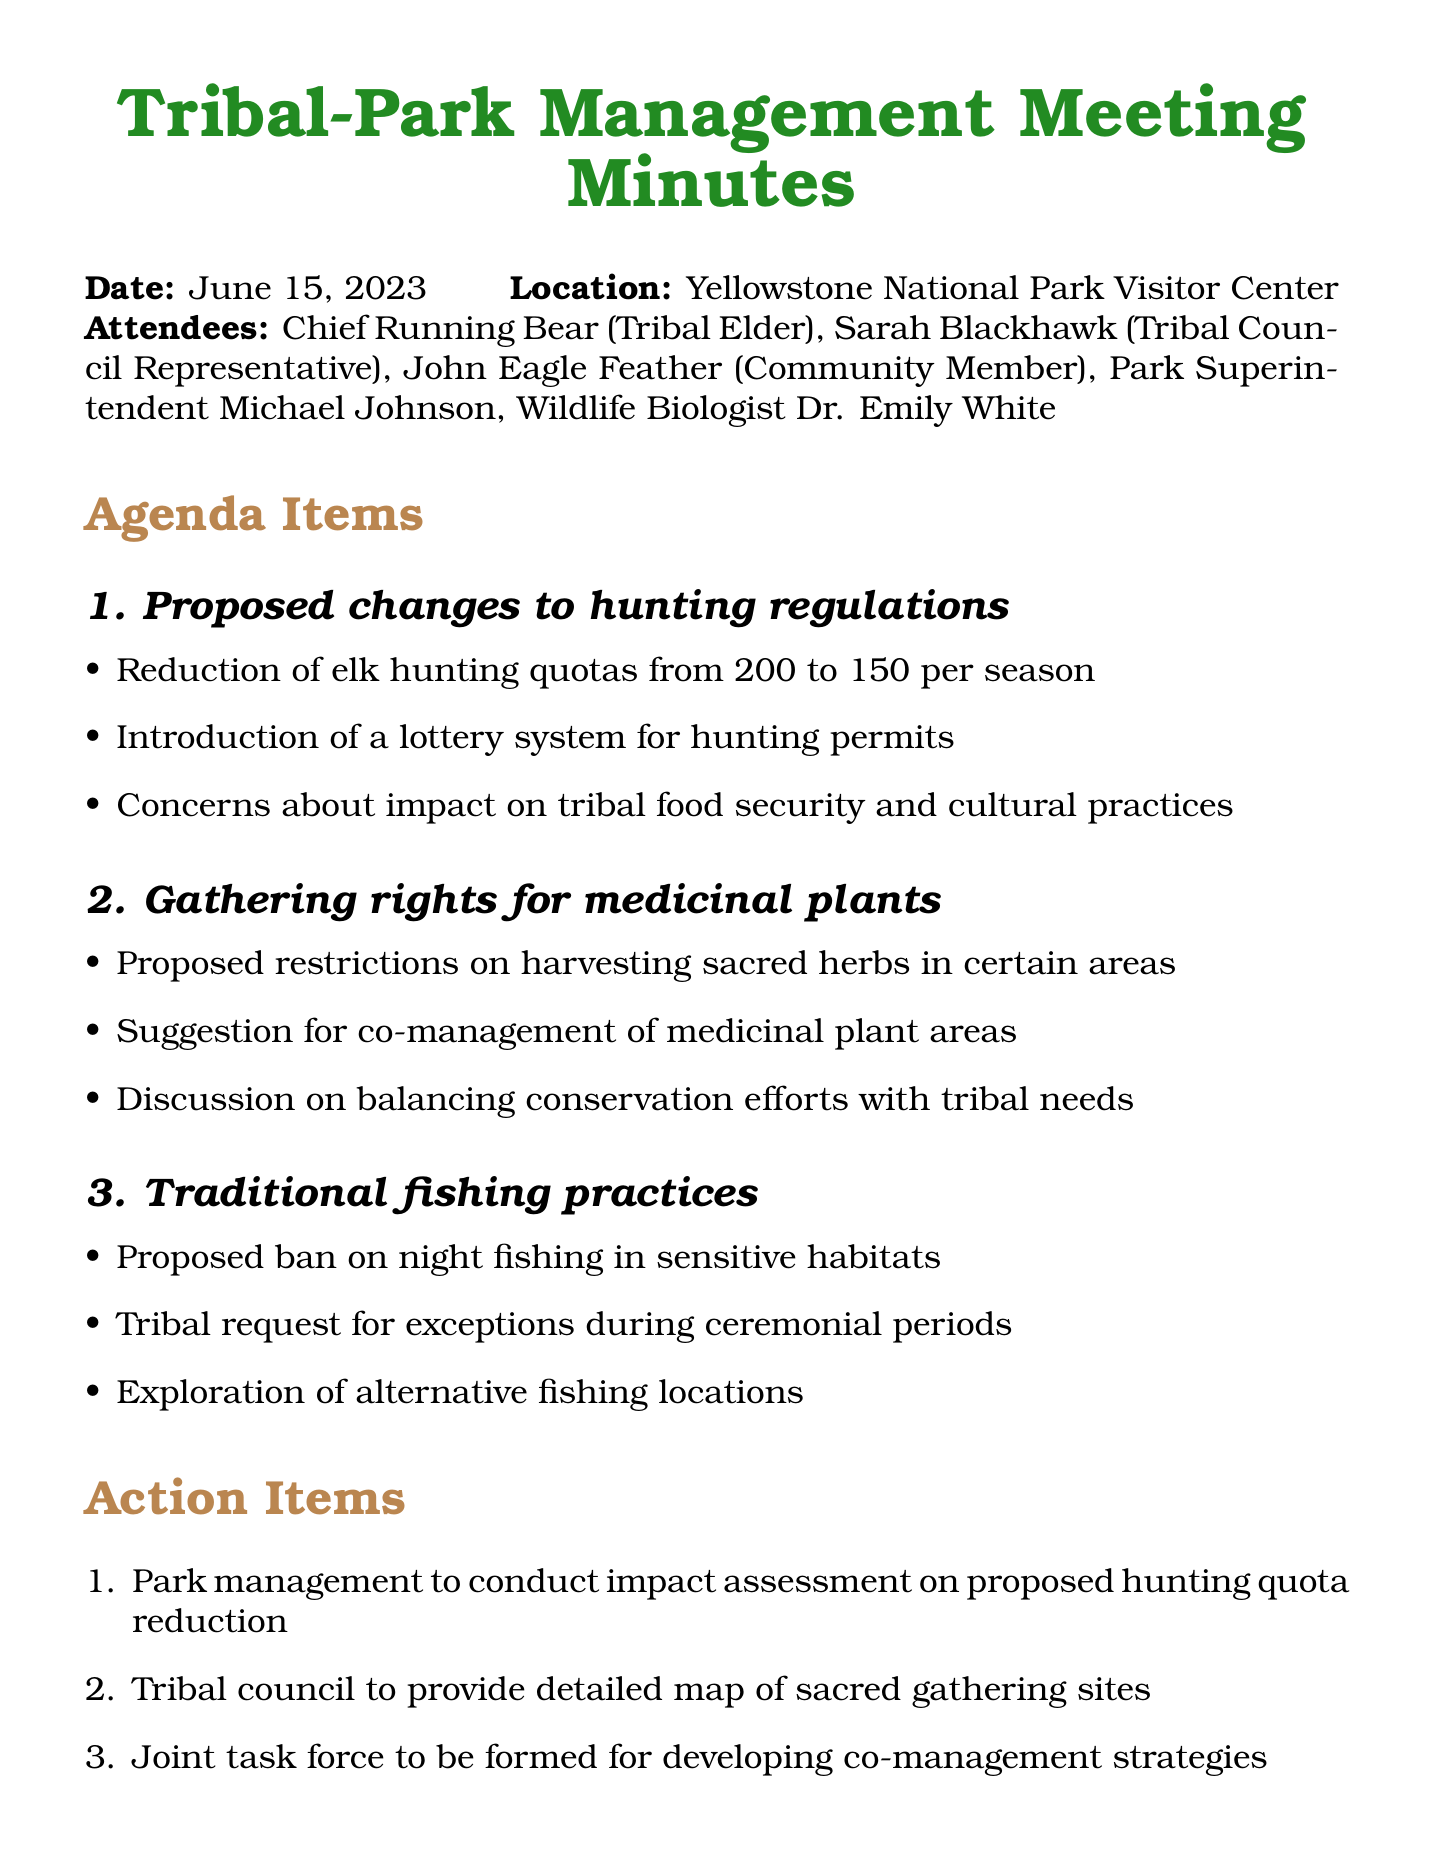What is the date of the meeting? The date of the meeting is clearly mentioned in the document as June 15, 2023.
Answer: June 15, 2023 Who is the Tribal Elder attending? The document lists Chief Running Bear as a Tribal Elder among the attendees.
Answer: Chief Running Bear What is the proposed elk hunting quota per season? The document states that the proposed reduction of elk hunting quotas is from 200 to 150 per season.
Answer: 150 What key concern was raised regarding hunting regulations? The document highlights concerns about the impact on tribal food security and cultural practices as a key point.
Answer: Impact on tribal food security and cultural practices What action item involves the Tribal Council? The action item mentions that the Tribal Council is to provide a detailed map of sacred gathering sites.
Answer: Provide detailed map of sacred gathering sites What will be held between August 5-15, 2023? The document specifies that a public consultation is scheduled during this timeframe.
Answer: Public consultation How many attendees were present at the meeting? The number of attendees can be counted from the list provided in the meeting details section.
Answer: Five What topic is related to traditional fishing practices? The document notes a proposed ban on night fishing in sensitive habitats as related to traditional fishing practices.
Answer: Proposed ban on night fishing What is the next meeting date mentioned? The document mentions July 20, 2023, as the date for the follow-up meeting.
Answer: July 20, 2023 